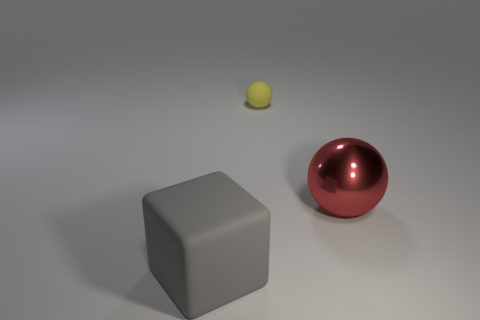Add 3 tiny cyan metallic cylinders. How many objects exist? 6 Subtract all blocks. How many objects are left? 2 Add 2 small yellow matte balls. How many small yellow matte balls are left? 3 Add 1 big shiny cylinders. How many big shiny cylinders exist? 1 Subtract 0 brown cylinders. How many objects are left? 3 Subtract all matte balls. Subtract all green metal cylinders. How many objects are left? 2 